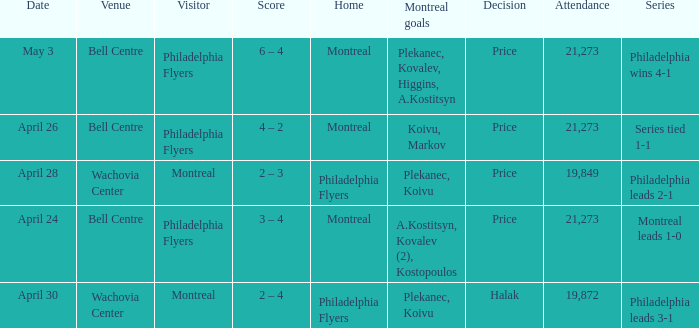What was the average attendance when the decision was price and montreal were the visitors? 19849.0. 